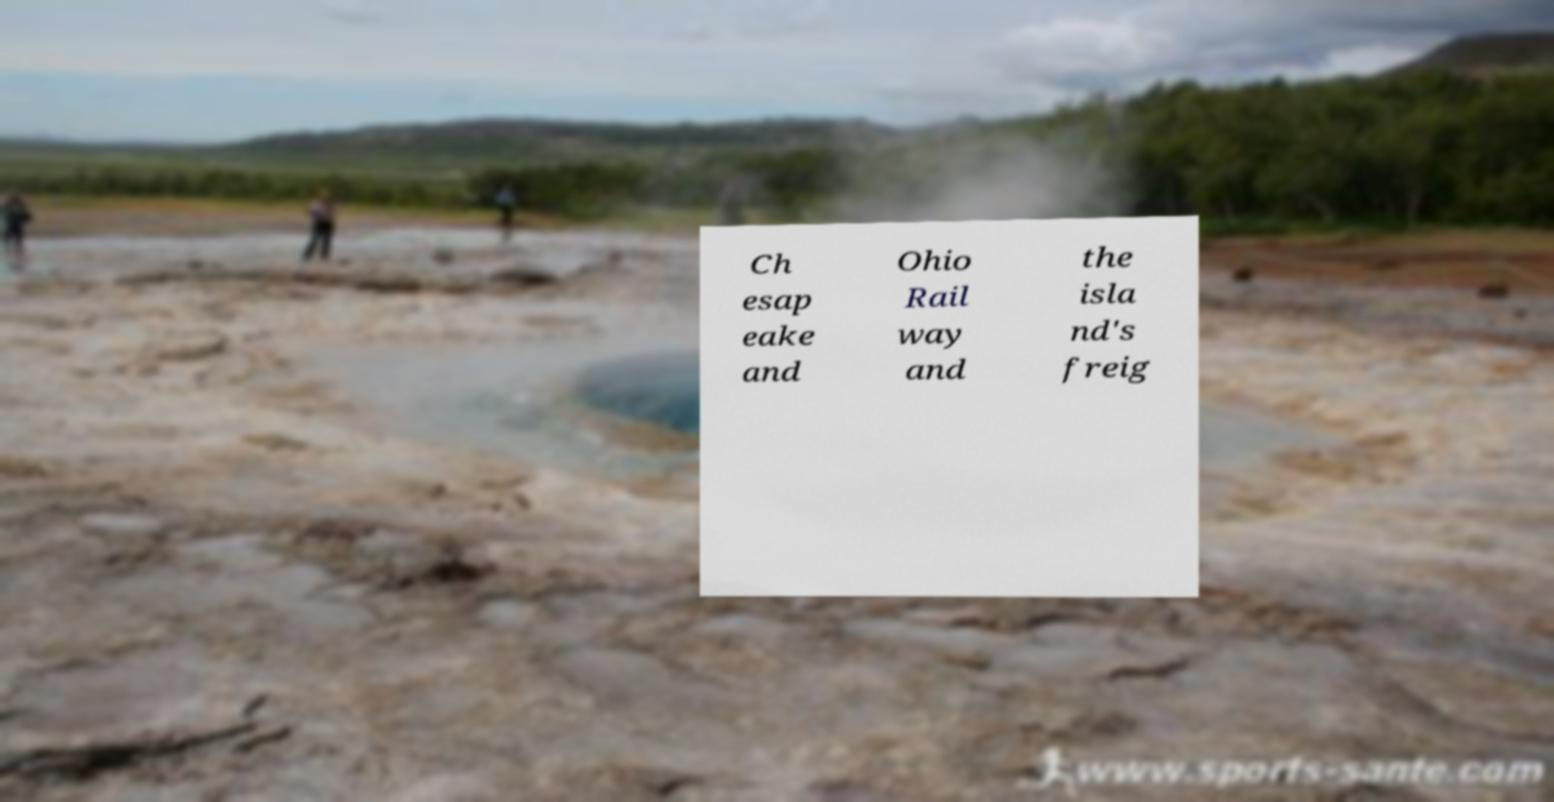Can you accurately transcribe the text from the provided image for me? Ch esap eake and Ohio Rail way and the isla nd's freig 